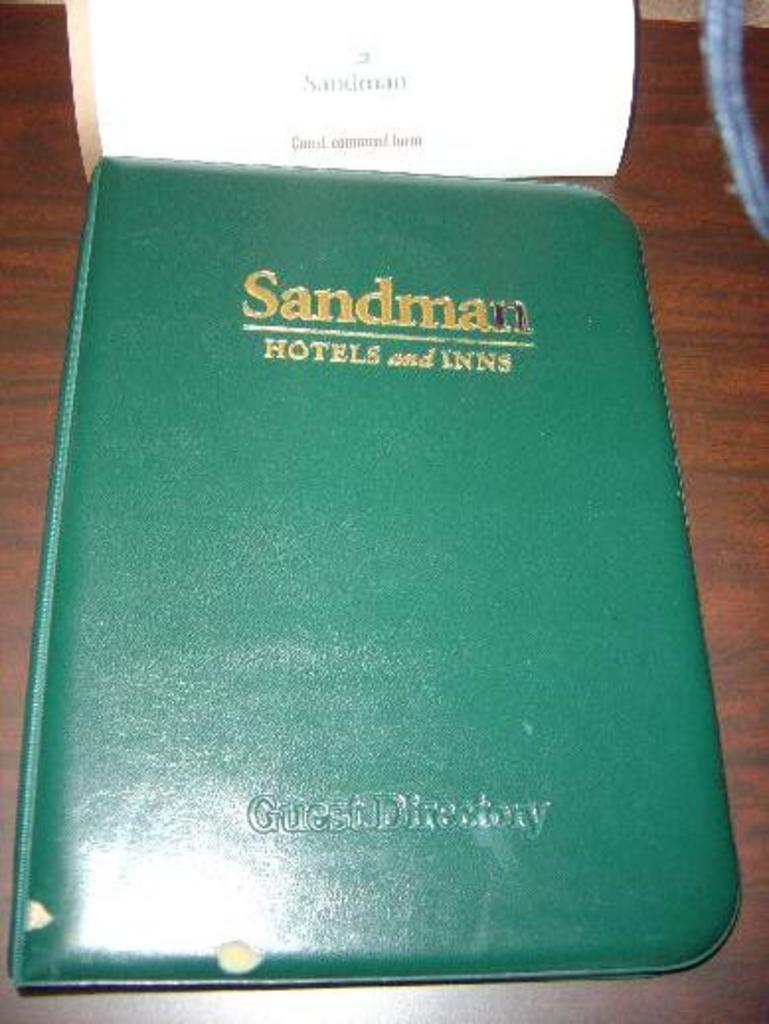<image>
Offer a succinct explanation of the picture presented. A guest directory is green and has Sandman printed on the top in gold lettering. 